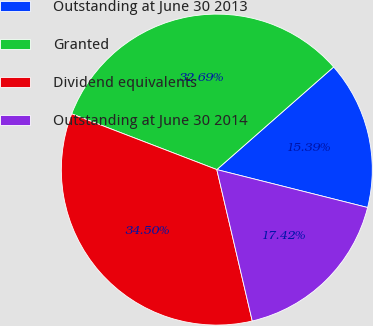<chart> <loc_0><loc_0><loc_500><loc_500><pie_chart><fcel>Outstanding at June 30 2013<fcel>Granted<fcel>Dividend equivalents<fcel>Outstanding at June 30 2014<nl><fcel>15.39%<fcel>32.69%<fcel>34.5%<fcel>17.42%<nl></chart> 